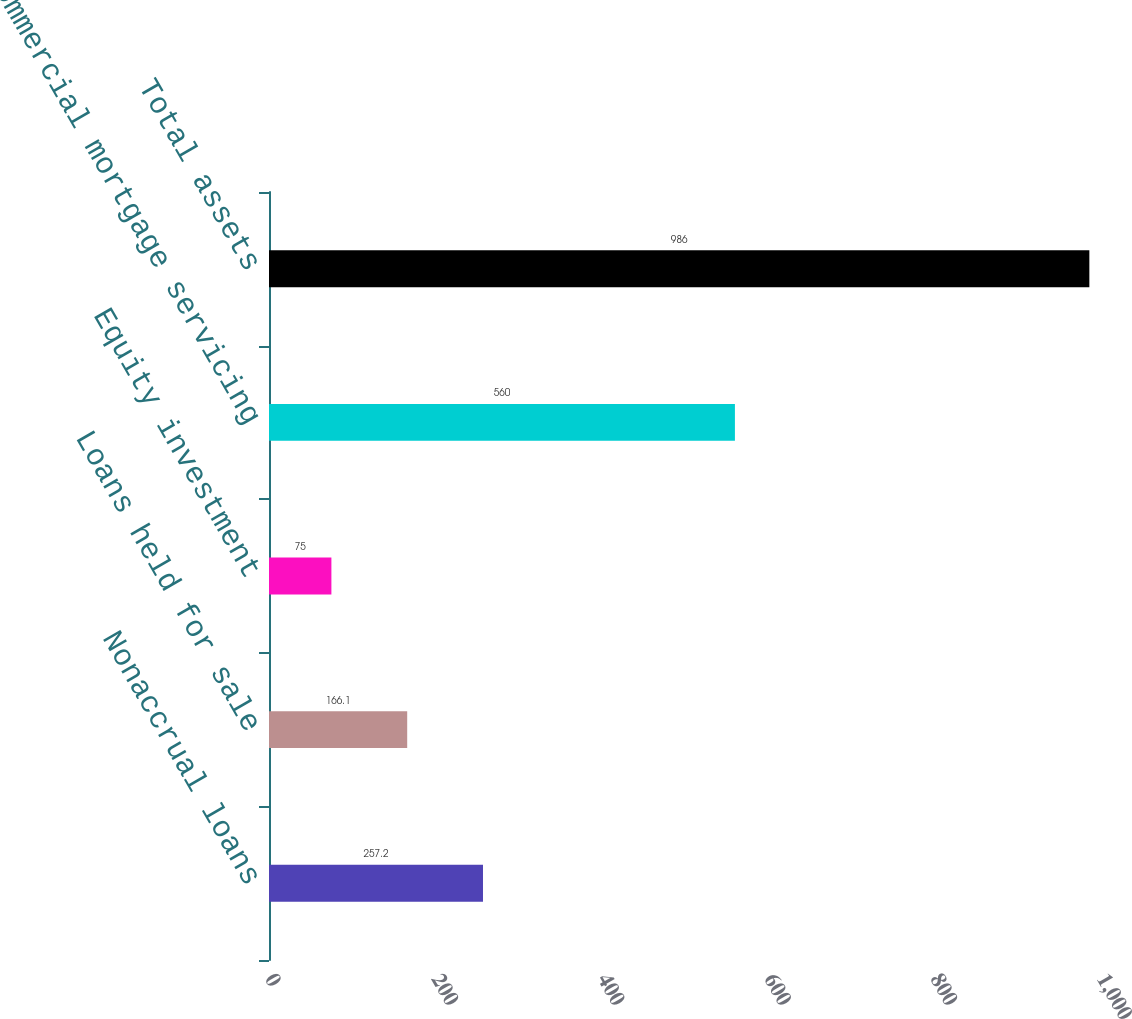<chart> <loc_0><loc_0><loc_500><loc_500><bar_chart><fcel>Nonaccrual loans<fcel>Loans held for sale<fcel>Equity investment<fcel>Commercial mortgage servicing<fcel>Total assets<nl><fcel>257.2<fcel>166.1<fcel>75<fcel>560<fcel>986<nl></chart> 